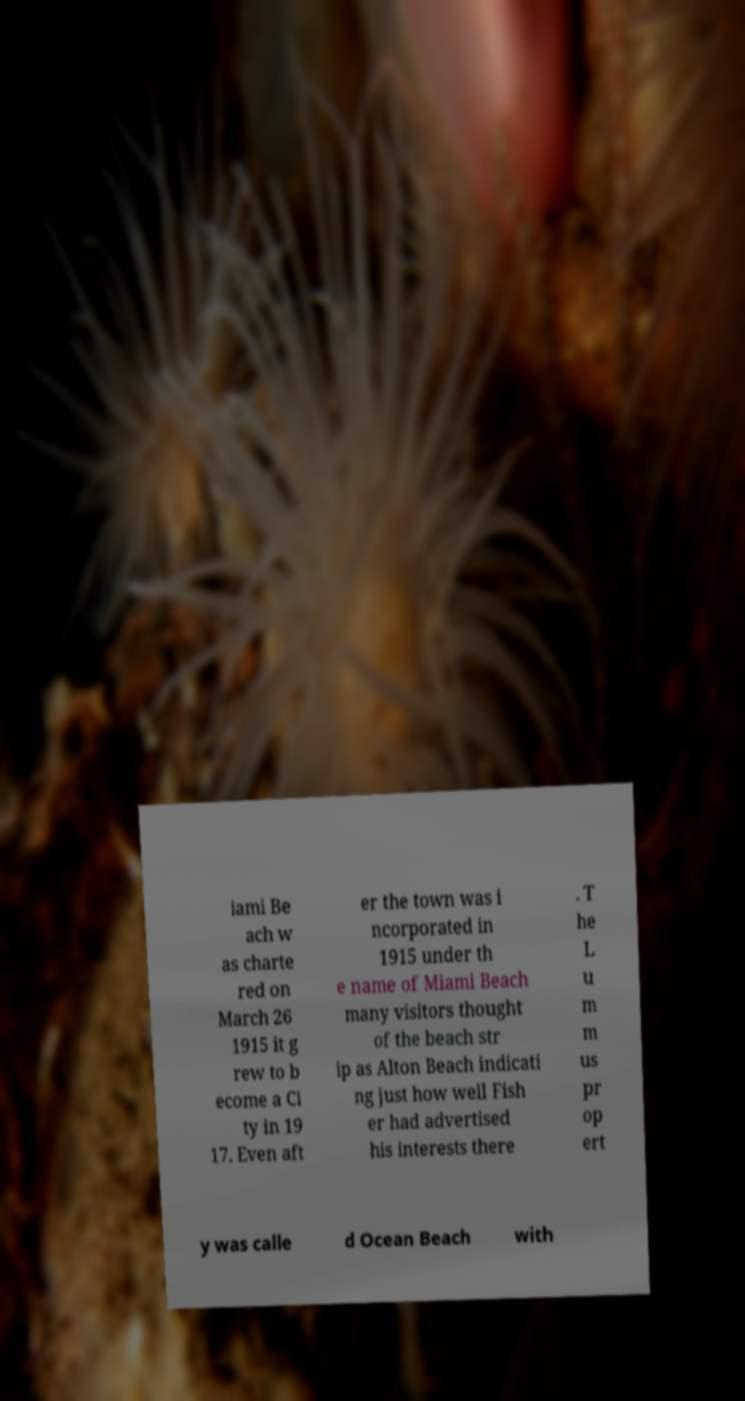There's text embedded in this image that I need extracted. Can you transcribe it verbatim? iami Be ach w as charte red on March 26 1915 it g rew to b ecome a Ci ty in 19 17. Even aft er the town was i ncorporated in 1915 under th e name of Miami Beach many visitors thought of the beach str ip as Alton Beach indicati ng just how well Fish er had advertised his interests there . T he L u m m us pr op ert y was calle d Ocean Beach with 